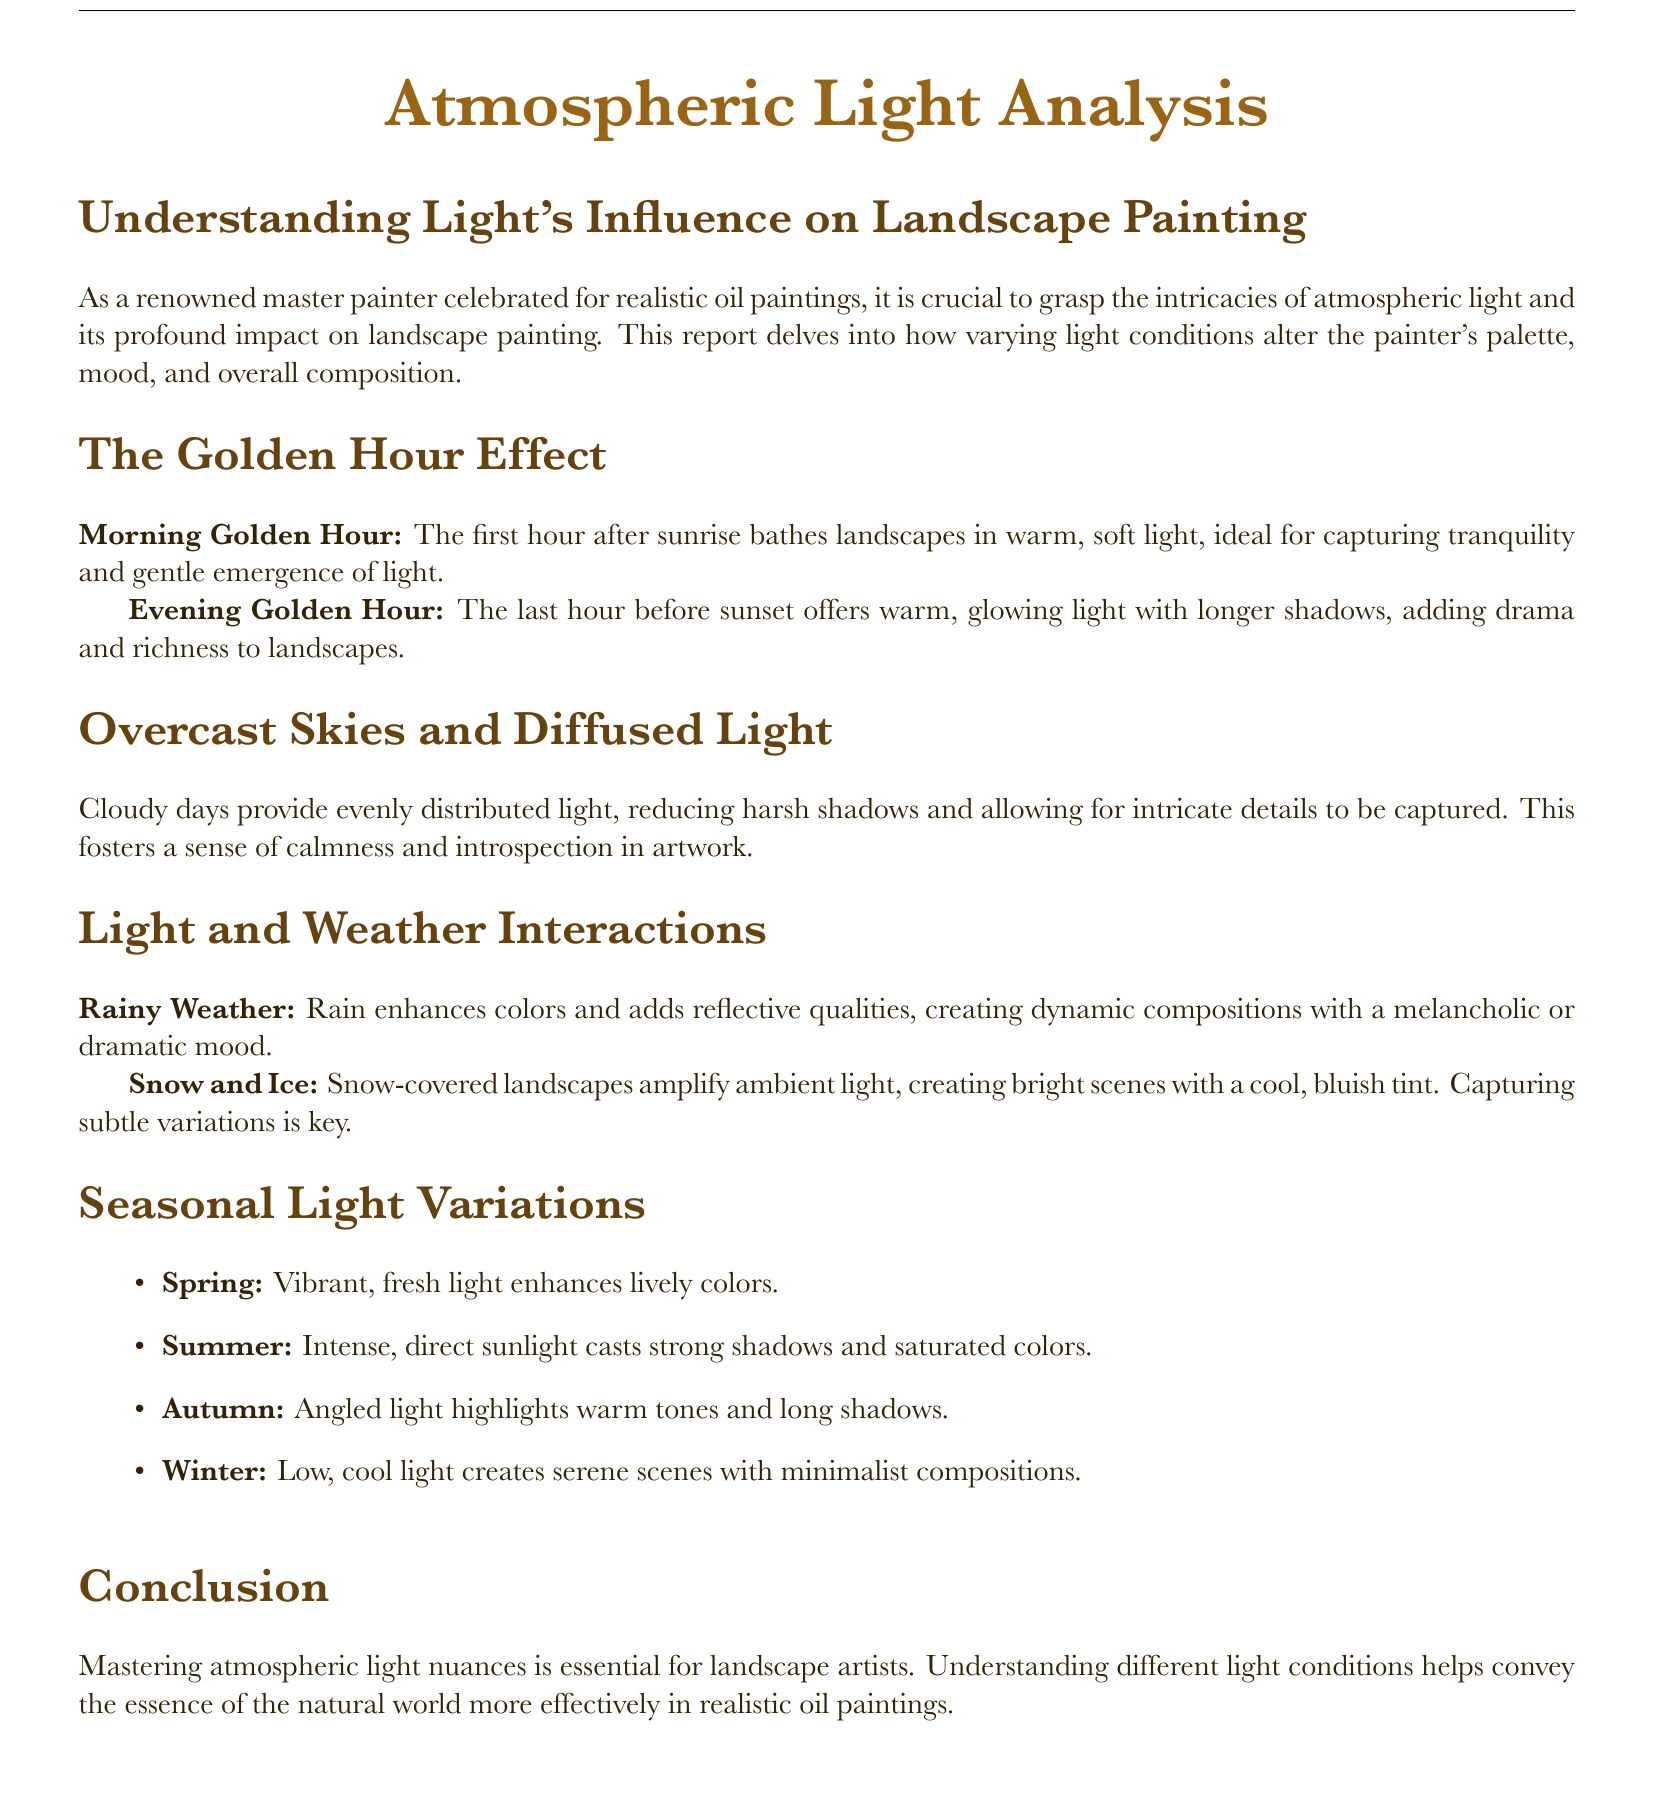What is the main focus of the document? The document focuses on analyzing atmospheric light and its influence on landscape painting.
Answer: atmospheric light What are the two types of golden hour mentioned? The document mentions the Morning Golden Hour and Evening Golden Hour as two types.
Answer: Morning, Evening What effect does overcast sky have on light? The document explains that overcast skies provide evenly distributed light, reducing harsh shadows.
Answer: reduces harsh shadows What season is described as having intense, direct sunlight? According to the document, summer is characterized by intense, direct sunlight.
Answer: Summer What mood does rainy weather create in artwork? The document states that rainy weather can create a melancholic or dramatic mood.
Answer: melancholic How does snow affect the ambiance of a landscape? The document indicates that snow amplifies ambient light and creates bright scenes.
Answer: amplifies ambient light What is a key aspect to capture in snow-covered landscapes? The document notes that capturing subtle variations is key in snow-covered landscapes.
Answer: subtle variations Which seasonal light variation enhances lively colors? Spring is the season described as enhancing lively colors in the document.
Answer: Spring What does the conclusion emphasize for landscape artists? The conclusion emphasizes the importance of mastering atmospheric light nuances for landscape artists.
Answer: mastering atmospheric light nuances 